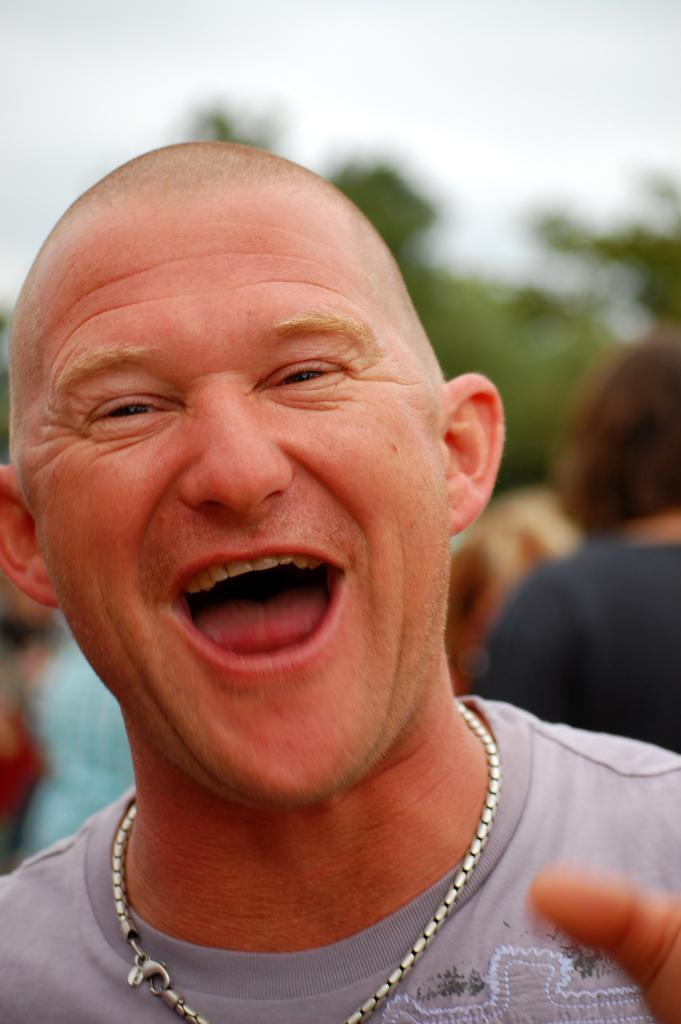Can you describe this image briefly? In this picture we can see a man is smiling and behind the man there are some people, trees and a sky. 